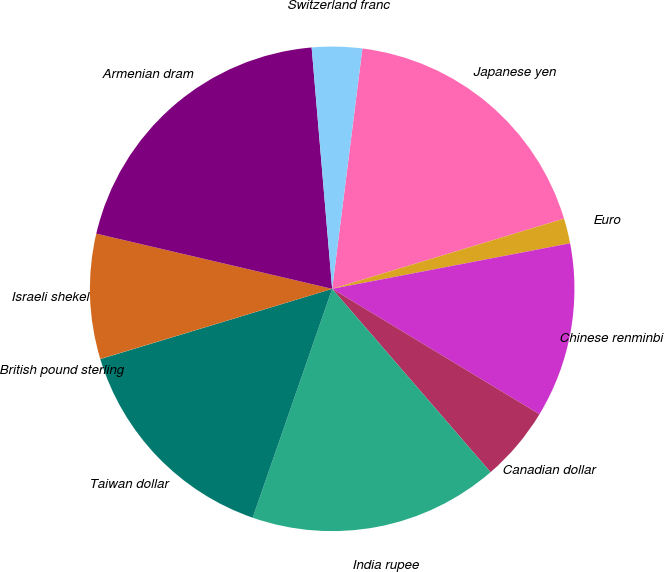Convert chart to OTSL. <chart><loc_0><loc_0><loc_500><loc_500><pie_chart><fcel>Japanese yen<fcel>Euro<fcel>Chinese renminbi<fcel>Canadian dollar<fcel>India rupee<fcel>Taiwan dollar<fcel>British pound sterling<fcel>Israeli shekel<fcel>Armenian dram<fcel>Switzerland franc<nl><fcel>18.33%<fcel>1.67%<fcel>11.67%<fcel>5.0%<fcel>16.66%<fcel>15.0%<fcel>0.01%<fcel>8.33%<fcel>19.99%<fcel>3.34%<nl></chart> 